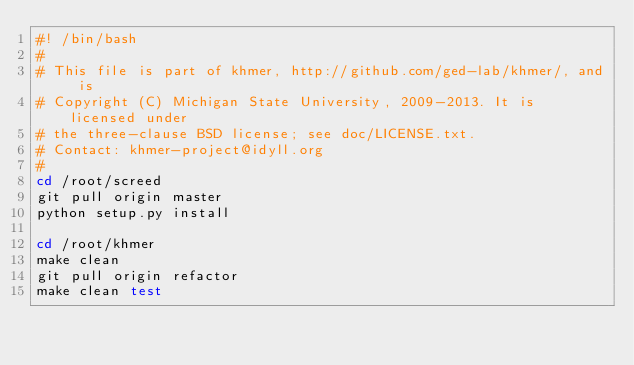Convert code to text. <code><loc_0><loc_0><loc_500><loc_500><_Bash_>#! /bin/bash
#
# This file is part of khmer, http://github.com/ged-lab/khmer/, and is
# Copyright (C) Michigan State University, 2009-2013. It is licensed under
# the three-clause BSD license; see doc/LICENSE.txt. 
# Contact: khmer-project@idyll.org
#
cd /root/screed
git pull origin master
python setup.py install

cd /root/khmer
make clean
git pull origin refactor
make clean test
</code> 